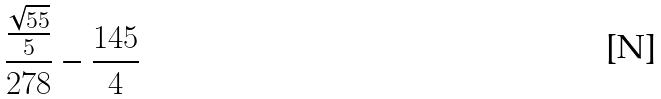<formula> <loc_0><loc_0><loc_500><loc_500>\frac { \frac { \sqrt { 5 5 } } { 5 } } { 2 7 8 } - \frac { 1 4 5 } { 4 }</formula> 